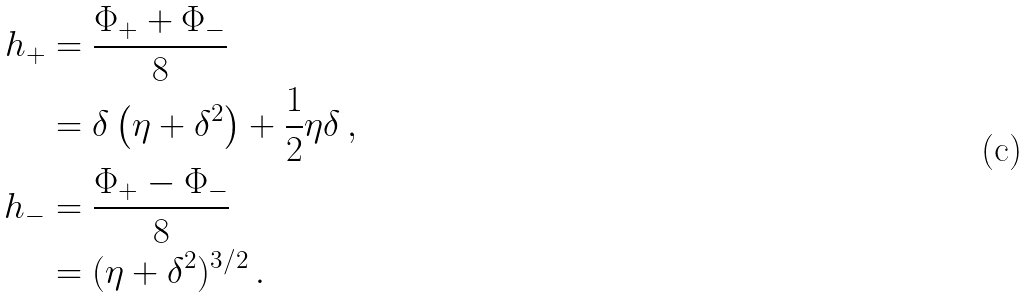Convert formula to latex. <formula><loc_0><loc_0><loc_500><loc_500>\ h _ { + } & = \frac { \Phi _ { + } + \Phi _ { - } } { 8 } \\ & = \delta \left ( \eta + \delta ^ { 2 } \right ) + \frac { 1 } { 2 } \eta \delta \, , \\ \ h _ { - } & = \frac { \Phi _ { + } - \Phi _ { - } } { 8 } \\ & = ( \eta + \delta ^ { 2 } ) ^ { 3 / 2 } \, .</formula> 